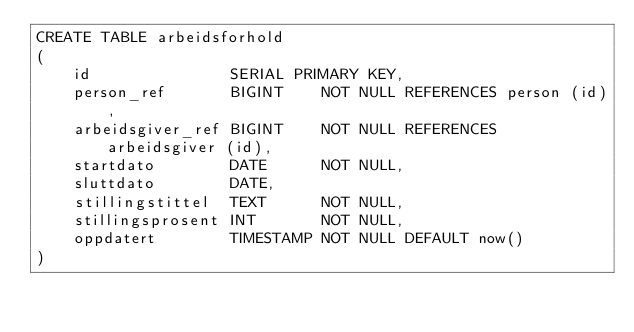<code> <loc_0><loc_0><loc_500><loc_500><_SQL_>CREATE TABLE arbeidsforhold
(
    id               SERIAL PRIMARY KEY,
    person_ref       BIGINT    NOT NULL REFERENCES person (id),
    arbeidsgiver_ref BIGINT    NOT NULL REFERENCES arbeidsgiver (id),
    startdato        DATE      NOT NULL,
    sluttdato        DATE,
    stillingstittel  TEXT      NOT NULL,
    stillingsprosent INT       NOT NULL,
    oppdatert        TIMESTAMP NOT NULL DEFAULT now()
)
</code> 